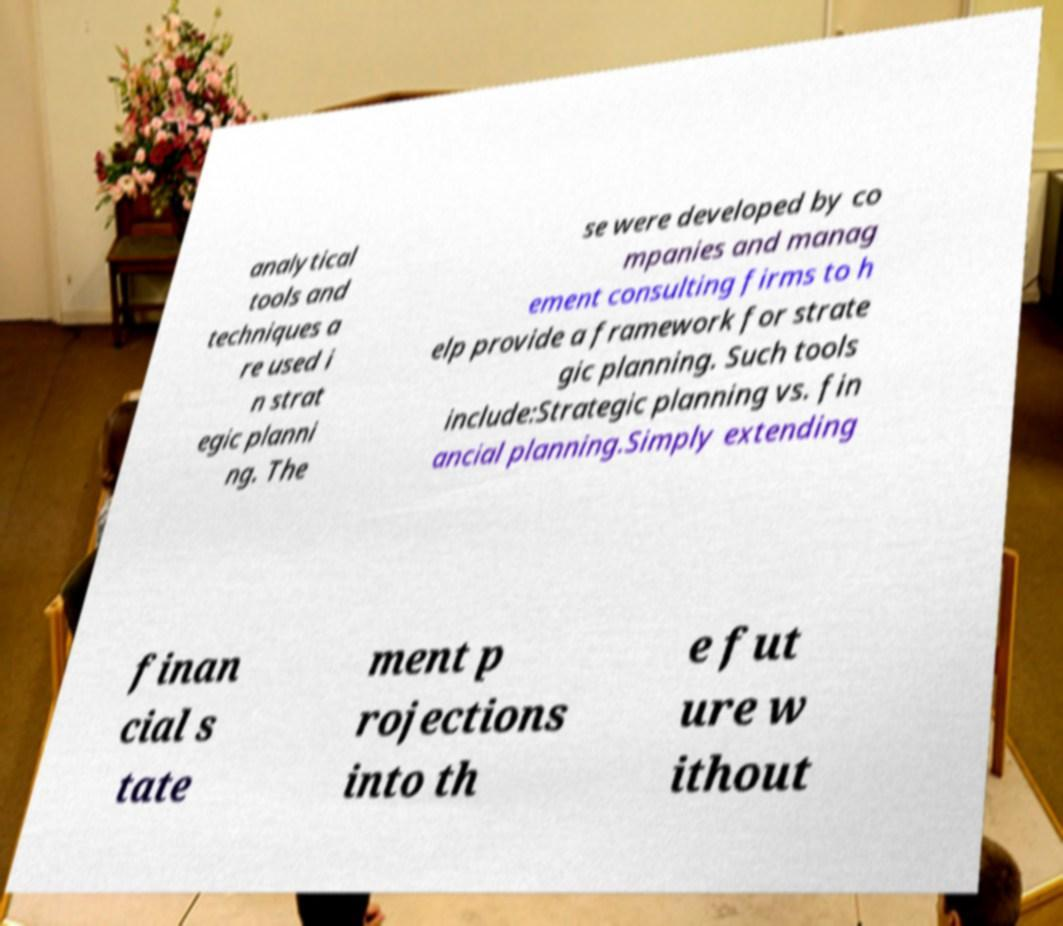What messages or text are displayed in this image? I need them in a readable, typed format. analytical tools and techniques a re used i n strat egic planni ng. The se were developed by co mpanies and manag ement consulting firms to h elp provide a framework for strate gic planning. Such tools include:Strategic planning vs. fin ancial planning.Simply extending finan cial s tate ment p rojections into th e fut ure w ithout 